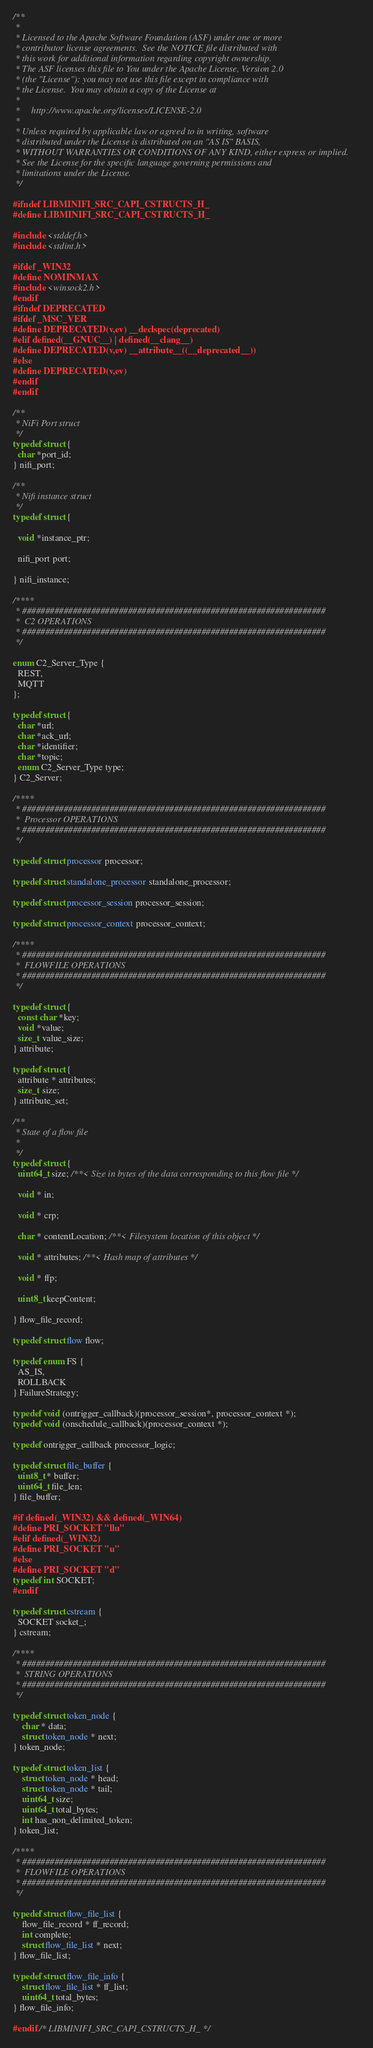<code> <loc_0><loc_0><loc_500><loc_500><_C_>/**
 *
 * Licensed to the Apache Software Foundation (ASF) under one or more
 * contributor license agreements.  See the NOTICE file distributed with
 * this work for additional information regarding copyright ownership.
 * The ASF licenses this file to You under the Apache License, Version 2.0
 * (the "License"); you may not use this file except in compliance with
 * the License.  You may obtain a copy of the License at
 *
 *     http://www.apache.org/licenses/LICENSE-2.0
 *
 * Unless required by applicable law or agreed to in writing, software
 * distributed under the License is distributed on an "AS IS" BASIS,
 * WITHOUT WARRANTIES OR CONDITIONS OF ANY KIND, either express or implied.
 * See the License for the specific language governing permissions and
 * limitations under the License.
 */

#ifndef LIBMINIFI_SRC_CAPI_CSTRUCTS_H_
#define LIBMINIFI_SRC_CAPI_CSTRUCTS_H_

#include <stddef.h>
#include <stdint.h>

#ifdef _WIN32
#define NOMINMAX
#include <winsock2.h>
#endif
#ifndef DEPRECATED
#ifdef _MSC_VER
#define DEPRECATED(v,ev) __declspec(deprecated)
#elif defined(__GNUC__) | defined(__clang__)
#define DEPRECATED(v,ev) __attribute__((__deprecated__))
#else
#define DEPRECATED(v,ev)
#endif
#endif

/**
 * NiFi Port struct
 */
typedef struct {
  char *port_id;
} nifi_port;

/**
 * Nifi instance struct
 */
typedef struct {

  void *instance_ptr;

  nifi_port port;

} nifi_instance;

/****
 * ##################################################################
 *  C2 OPERATIONS
 * ##################################################################
 */

enum C2_Server_Type {
  REST,
  MQTT
};

typedef struct {
  char *url;
  char *ack_url;
  char *identifier;
  char *topic;
  enum C2_Server_Type type;
} C2_Server;

/****
 * ##################################################################
 *  Processor OPERATIONS
 * ##################################################################
 */

typedef struct processor processor;

typedef struct standalone_processor standalone_processor;

typedef struct processor_session processor_session;

typedef struct processor_context processor_context;

/****
 * ##################################################################
 *  FLOWFILE OPERATIONS
 * ##################################################################
 */

typedef struct {
  const char *key;
  void *value;
  size_t value_size;
} attribute;

typedef struct {
  attribute * attributes;
  size_t size;
} attribute_set;

/**
 * State of a flow file
 *
 */
typedef struct {
  uint64_t size; /**< Size in bytes of the data corresponding to this flow file */

  void * in;

  void * crp;

  char * contentLocation; /**< Filesystem location of this object */

  void * attributes; /**< Hash map of attributes */

  void * ffp;

  uint8_t keepContent;

} flow_file_record;

typedef struct flow flow;

typedef enum FS {
  AS_IS,
  ROLLBACK
} FailureStrategy;

typedef void (ontrigger_callback)(processor_session*, processor_context *);
typedef void (onschedule_callback)(processor_context *);

typedef ontrigger_callback processor_logic;

typedef struct file_buffer {
  uint8_t * buffer;
  uint64_t file_len;
} file_buffer;

#if defined(_WIN32) && defined(_WIN64)
#define PRI_SOCKET "llu"
#elif defined(_WIN32)
#define PRI_SOCKET "u"
#else
#define PRI_SOCKET "d"
typedef int SOCKET;
#endif

typedef struct cstream {
  SOCKET socket_;
} cstream;

/****
 * ##################################################################
 *  STRING OPERATIONS
 * ##################################################################
 */

typedef struct token_node {
    char * data;
    struct token_node * next;
} token_node;

typedef struct token_list {
    struct token_node * head;
    struct token_node * tail;
    uint64_t size;
    uint64_t total_bytes;
    int has_non_delimited_token;
} token_list;

/****
 * ##################################################################
 *  FLOWFILE OPERATIONS
 * ##################################################################
 */

typedef struct flow_file_list {
    flow_file_record * ff_record;
    int complete;
    struct flow_file_list * next;
} flow_file_list;

typedef struct flow_file_info {
    struct flow_file_list * ff_list;
    uint64_t total_bytes;
} flow_file_info;

#endif /* LIBMINIFI_SRC_CAPI_CSTRUCTS_H_ */
</code> 